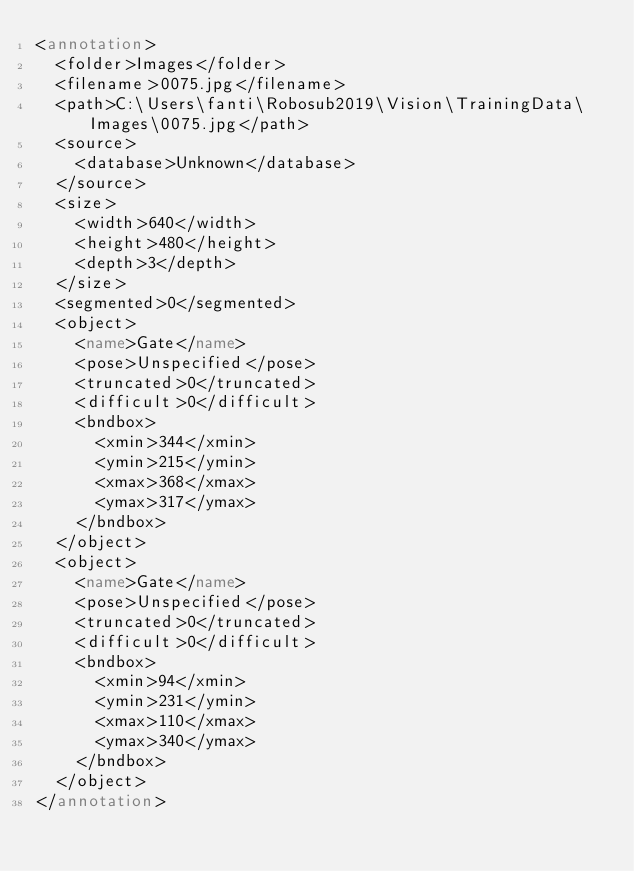Convert code to text. <code><loc_0><loc_0><loc_500><loc_500><_XML_><annotation>
	<folder>Images</folder>
	<filename>0075.jpg</filename>
	<path>C:\Users\fanti\Robosub2019\Vision\TrainingData\Images\0075.jpg</path>
	<source>
		<database>Unknown</database>
	</source>
	<size>
		<width>640</width>
		<height>480</height>
		<depth>3</depth>
	</size>
	<segmented>0</segmented>
	<object>
		<name>Gate</name>
		<pose>Unspecified</pose>
		<truncated>0</truncated>
		<difficult>0</difficult>
		<bndbox>
			<xmin>344</xmin>
			<ymin>215</ymin>
			<xmax>368</xmax>
			<ymax>317</ymax>
		</bndbox>
	</object>
	<object>
		<name>Gate</name>
		<pose>Unspecified</pose>
		<truncated>0</truncated>
		<difficult>0</difficult>
		<bndbox>
			<xmin>94</xmin>
			<ymin>231</ymin>
			<xmax>110</xmax>
			<ymax>340</ymax>
		</bndbox>
	</object>
</annotation>
</code> 